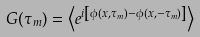<formula> <loc_0><loc_0><loc_500><loc_500>G ( \tau _ { m } ) = \left \langle e ^ { i \left [ \phi ( x , \tau _ { m } ) - \phi ( x , - \tau _ { m } ) \right ] } \right \rangle</formula> 